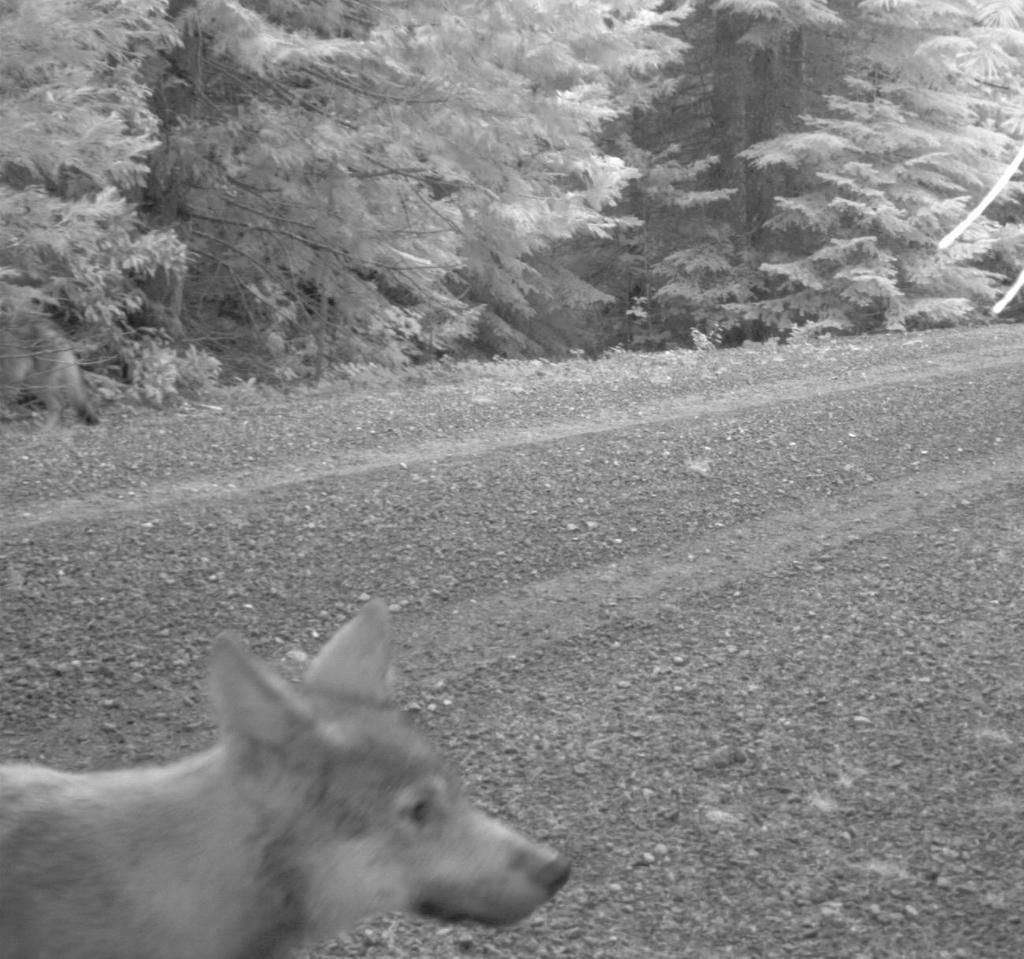What is the main feature of the image? There is a road in the image. Can you describe the animal at the bottom of the image? There is an animal at the bottom of the image, but its specific characteristics are not mentioned in the facts. What can be seen in the background of the image? Trees and plants are visible at the top of the image. What type of wine is being served at the river in the image? There is no mention of wine or a river in the image; it features a road, an animal, and trees and plants in the background. 